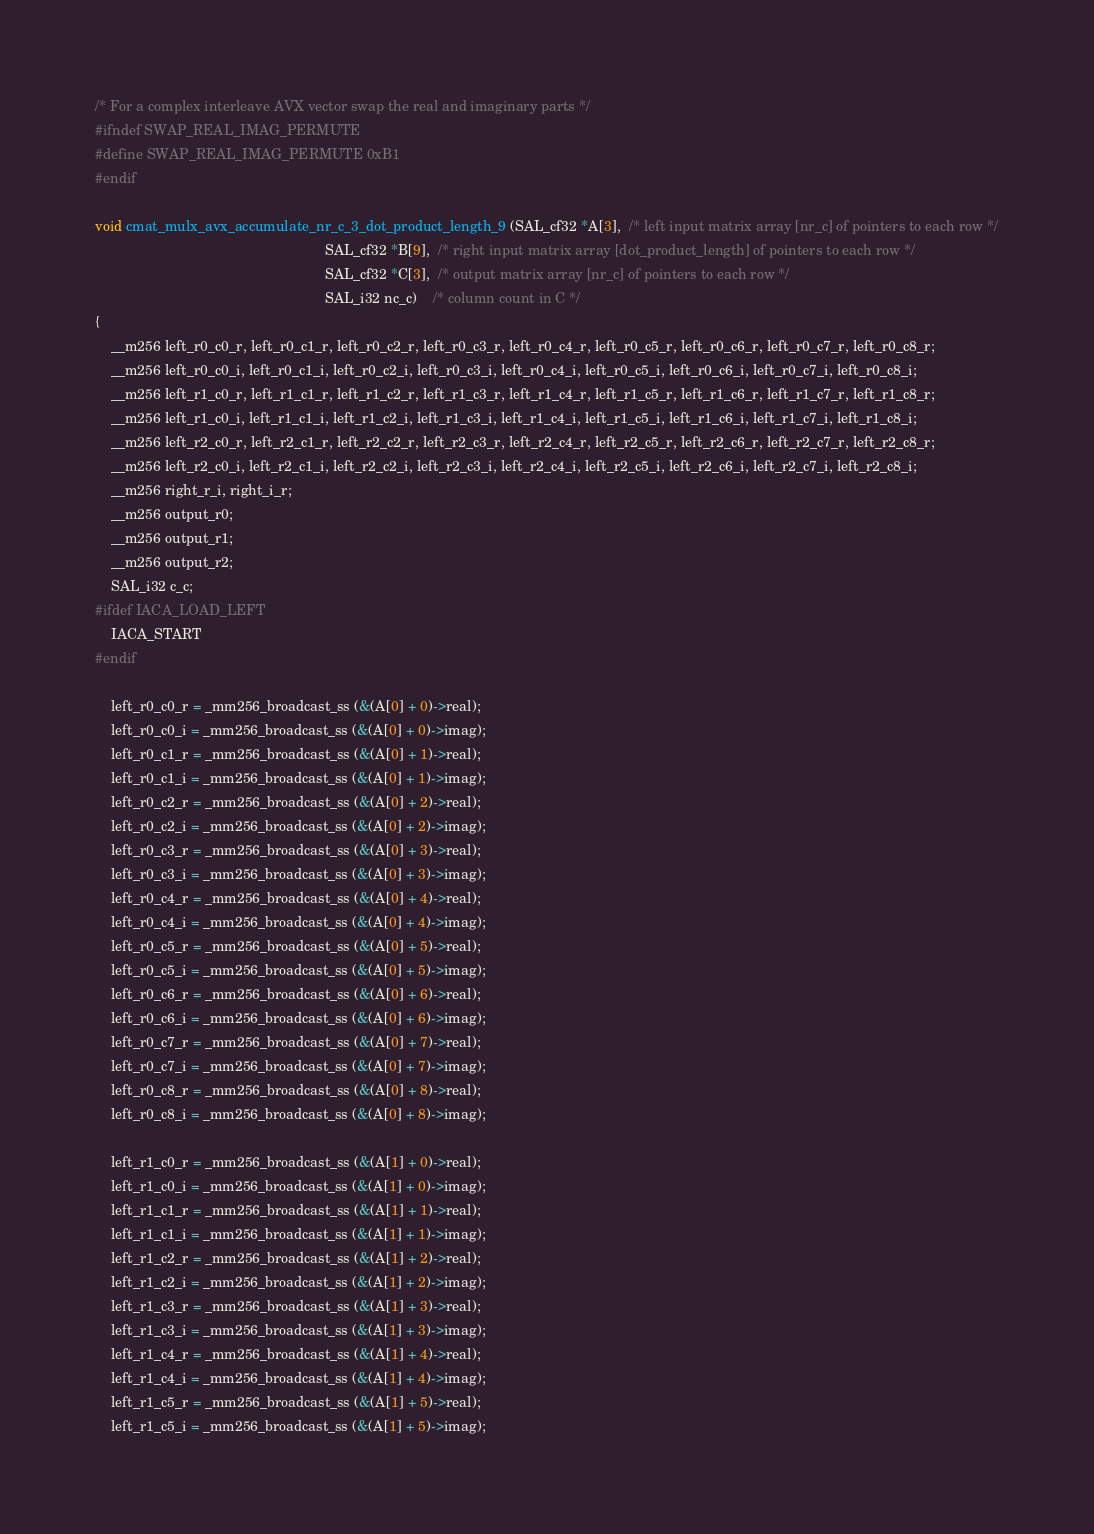<code> <loc_0><loc_0><loc_500><loc_500><_C_>/* For a complex interleave AVX vector swap the real and imaginary parts */
#ifndef SWAP_REAL_IMAG_PERMUTE
#define SWAP_REAL_IMAG_PERMUTE 0xB1
#endif

void cmat_mulx_avx_accumulate_nr_c_3_dot_product_length_9 (SAL_cf32 *A[3],  /* left input matrix array [nr_c] of pointers to each row */
                                                           SAL_cf32 *B[9],  /* right input matrix array [dot_product_length] of pointers to each row */
                                                           SAL_cf32 *C[3],  /* output matrix array [nr_c] of pointers to each row */
                                                           SAL_i32 nc_c)    /* column count in C */
{
    __m256 left_r0_c0_r, left_r0_c1_r, left_r0_c2_r, left_r0_c3_r, left_r0_c4_r, left_r0_c5_r, left_r0_c6_r, left_r0_c7_r, left_r0_c8_r;
    __m256 left_r0_c0_i, left_r0_c1_i, left_r0_c2_i, left_r0_c3_i, left_r0_c4_i, left_r0_c5_i, left_r0_c6_i, left_r0_c7_i, left_r0_c8_i;
    __m256 left_r1_c0_r, left_r1_c1_r, left_r1_c2_r, left_r1_c3_r, left_r1_c4_r, left_r1_c5_r, left_r1_c6_r, left_r1_c7_r, left_r1_c8_r;
    __m256 left_r1_c0_i, left_r1_c1_i, left_r1_c2_i, left_r1_c3_i, left_r1_c4_i, left_r1_c5_i, left_r1_c6_i, left_r1_c7_i, left_r1_c8_i;
    __m256 left_r2_c0_r, left_r2_c1_r, left_r2_c2_r, left_r2_c3_r, left_r2_c4_r, left_r2_c5_r, left_r2_c6_r, left_r2_c7_r, left_r2_c8_r;
    __m256 left_r2_c0_i, left_r2_c1_i, left_r2_c2_i, left_r2_c3_i, left_r2_c4_i, left_r2_c5_i, left_r2_c6_i, left_r2_c7_i, left_r2_c8_i;
    __m256 right_r_i, right_i_r;
    __m256 output_r0;
    __m256 output_r1;
    __m256 output_r2;
    SAL_i32 c_c;
#ifdef IACA_LOAD_LEFT
    IACA_START
#endif

    left_r0_c0_r = _mm256_broadcast_ss (&(A[0] + 0)->real);
    left_r0_c0_i = _mm256_broadcast_ss (&(A[0] + 0)->imag);
    left_r0_c1_r = _mm256_broadcast_ss (&(A[0] + 1)->real);
    left_r0_c1_i = _mm256_broadcast_ss (&(A[0] + 1)->imag);
    left_r0_c2_r = _mm256_broadcast_ss (&(A[0] + 2)->real);
    left_r0_c2_i = _mm256_broadcast_ss (&(A[0] + 2)->imag);
    left_r0_c3_r = _mm256_broadcast_ss (&(A[0] + 3)->real);
    left_r0_c3_i = _mm256_broadcast_ss (&(A[0] + 3)->imag);
    left_r0_c4_r = _mm256_broadcast_ss (&(A[0] + 4)->real);
    left_r0_c4_i = _mm256_broadcast_ss (&(A[0] + 4)->imag);
    left_r0_c5_r = _mm256_broadcast_ss (&(A[0] + 5)->real);
    left_r0_c5_i = _mm256_broadcast_ss (&(A[0] + 5)->imag);
    left_r0_c6_r = _mm256_broadcast_ss (&(A[0] + 6)->real);
    left_r0_c6_i = _mm256_broadcast_ss (&(A[0] + 6)->imag);
    left_r0_c7_r = _mm256_broadcast_ss (&(A[0] + 7)->real);
    left_r0_c7_i = _mm256_broadcast_ss (&(A[0] + 7)->imag);
    left_r0_c8_r = _mm256_broadcast_ss (&(A[0] + 8)->real);
    left_r0_c8_i = _mm256_broadcast_ss (&(A[0] + 8)->imag);

    left_r1_c0_r = _mm256_broadcast_ss (&(A[1] + 0)->real);
    left_r1_c0_i = _mm256_broadcast_ss (&(A[1] + 0)->imag);
    left_r1_c1_r = _mm256_broadcast_ss (&(A[1] + 1)->real);
    left_r1_c1_i = _mm256_broadcast_ss (&(A[1] + 1)->imag);
    left_r1_c2_r = _mm256_broadcast_ss (&(A[1] + 2)->real);
    left_r1_c2_i = _mm256_broadcast_ss (&(A[1] + 2)->imag);
    left_r1_c3_r = _mm256_broadcast_ss (&(A[1] + 3)->real);
    left_r1_c3_i = _mm256_broadcast_ss (&(A[1] + 3)->imag);
    left_r1_c4_r = _mm256_broadcast_ss (&(A[1] + 4)->real);
    left_r1_c4_i = _mm256_broadcast_ss (&(A[1] + 4)->imag);
    left_r1_c5_r = _mm256_broadcast_ss (&(A[1] + 5)->real);
    left_r1_c5_i = _mm256_broadcast_ss (&(A[1] + 5)->imag);</code> 